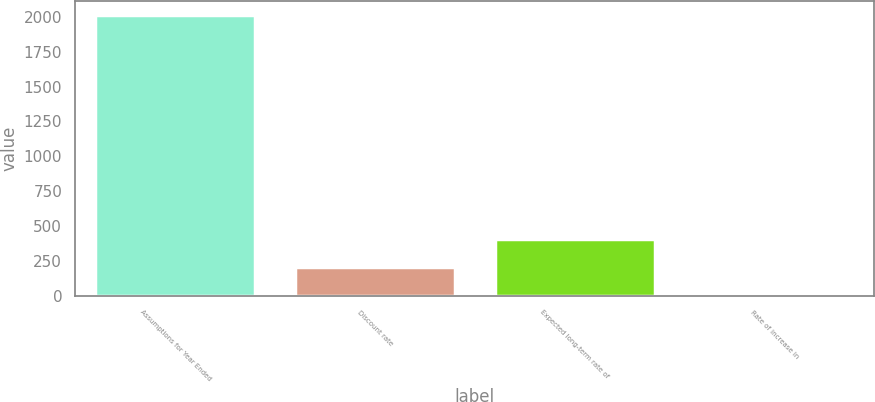Convert chart. <chart><loc_0><loc_0><loc_500><loc_500><bar_chart><fcel>Assumptions for Year Ended<fcel>Discount rate<fcel>Expected long-term rate of<fcel>Rate of increase in<nl><fcel>2013<fcel>204.71<fcel>405.63<fcel>3.79<nl></chart> 